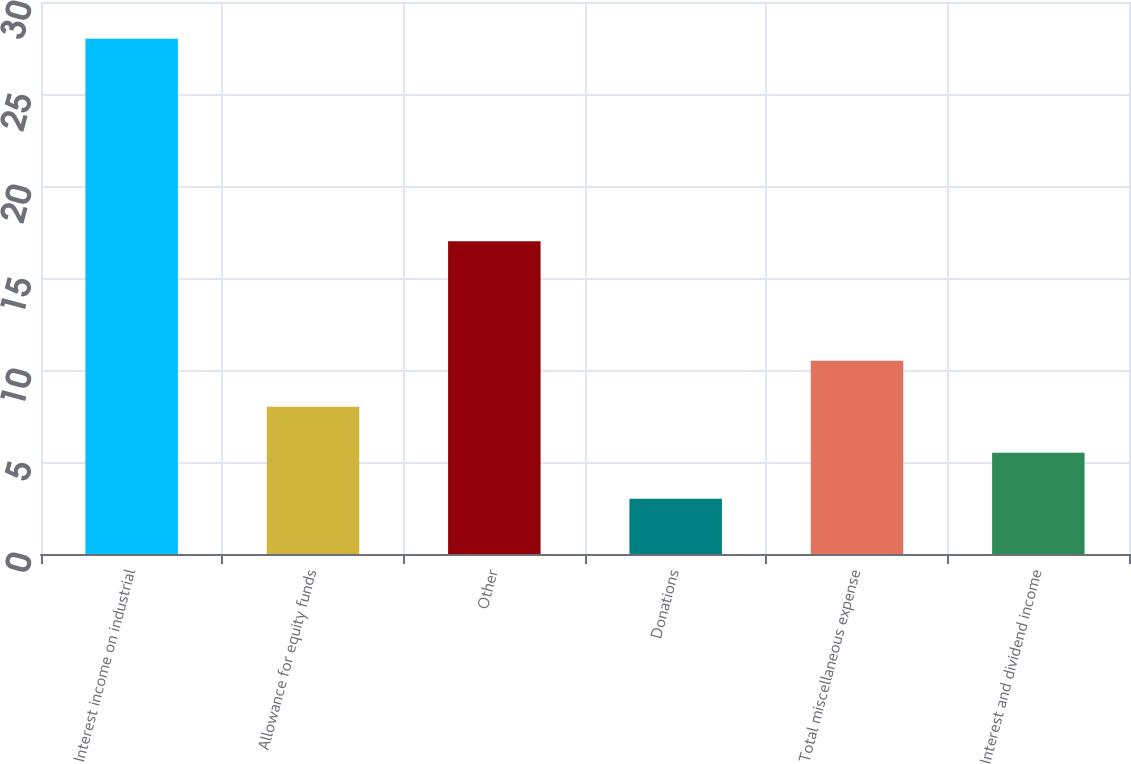<chart> <loc_0><loc_0><loc_500><loc_500><bar_chart><fcel>Interest income on industrial<fcel>Allowance for equity funds<fcel>Other<fcel>Donations<fcel>Total miscellaneous expense<fcel>Interest and dividend income<nl><fcel>28<fcel>8<fcel>17<fcel>3<fcel>10.5<fcel>5.5<nl></chart> 